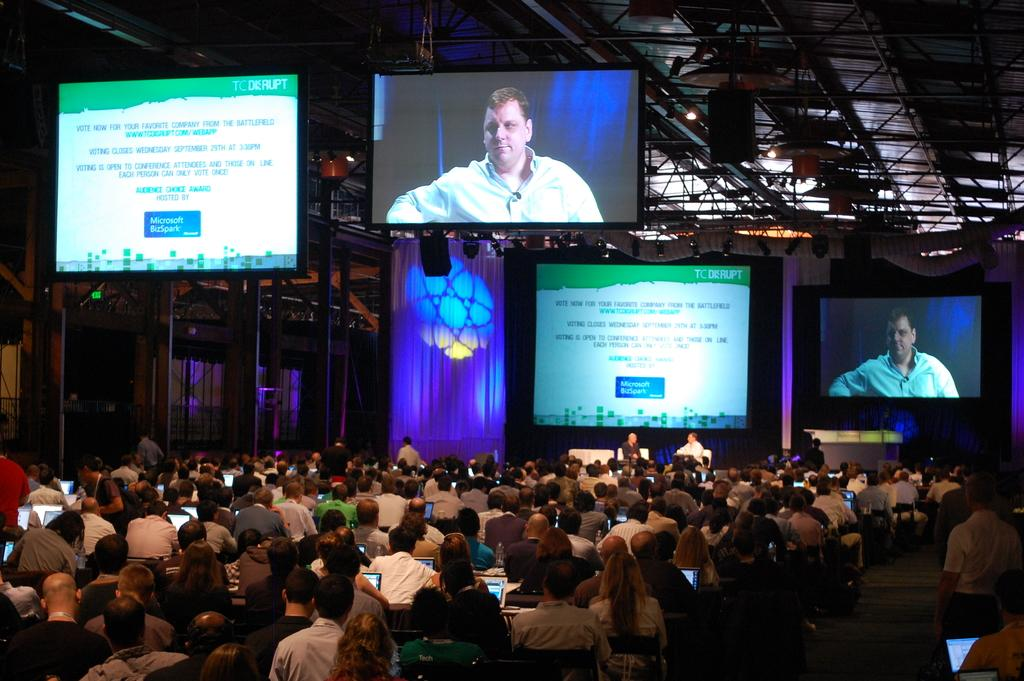What type of space is depicted in the image? The image shows the inside view of an auditorium. What electronic device can be seen in the auditorium? There is: There is an LED TV in the auditorium. Who is present in the auditorium? There is an audience in the auditorium. What lighting features are present in the auditorium? There are lights in the auditorium. What type of decorative element is present in the auditorium? There are curtains in the auditorium. What is the tendency of the money to behave in the image? There is no money present in the image, so it is not possible to determine its behavior. 